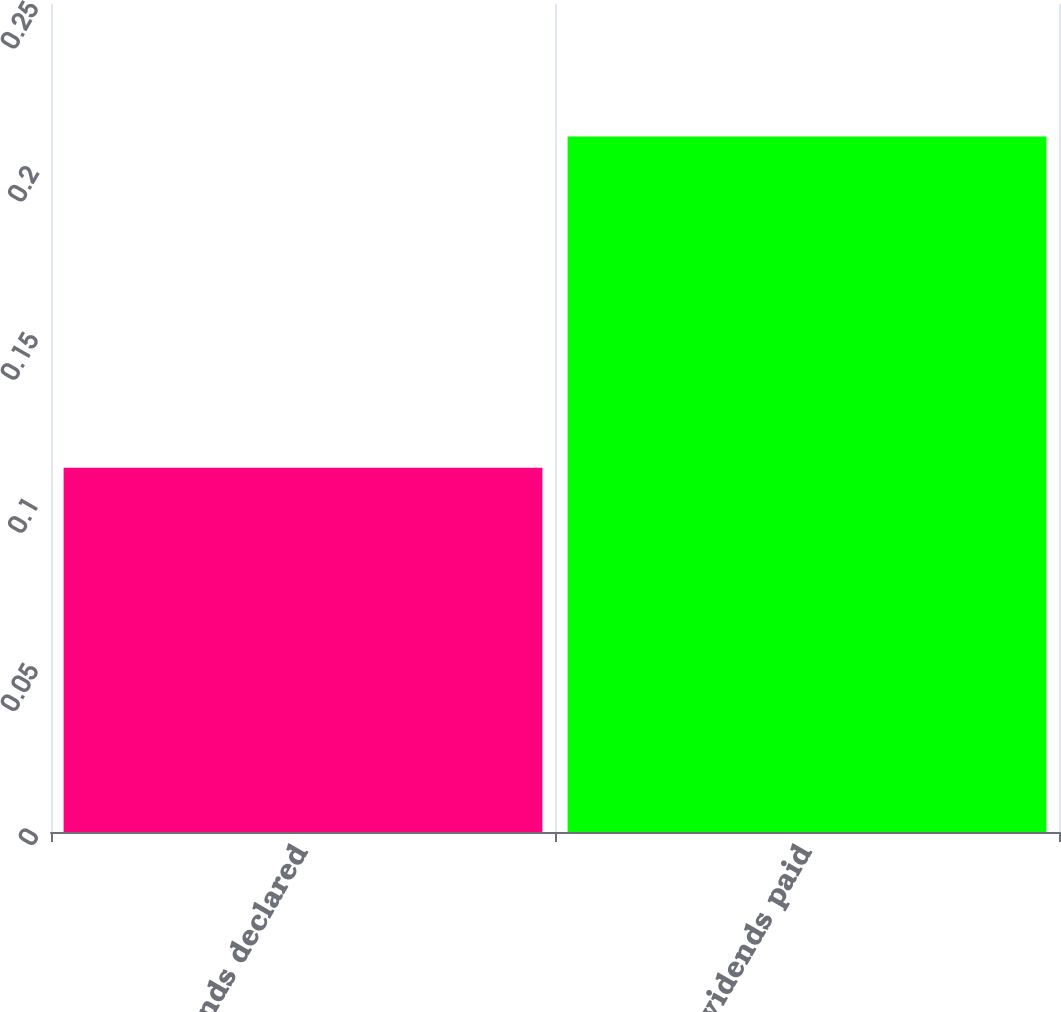Convert chart to OTSL. <chart><loc_0><loc_0><loc_500><loc_500><bar_chart><fcel>Dividends declared<fcel>Dividends paid<nl><fcel>0.11<fcel>0.21<nl></chart> 